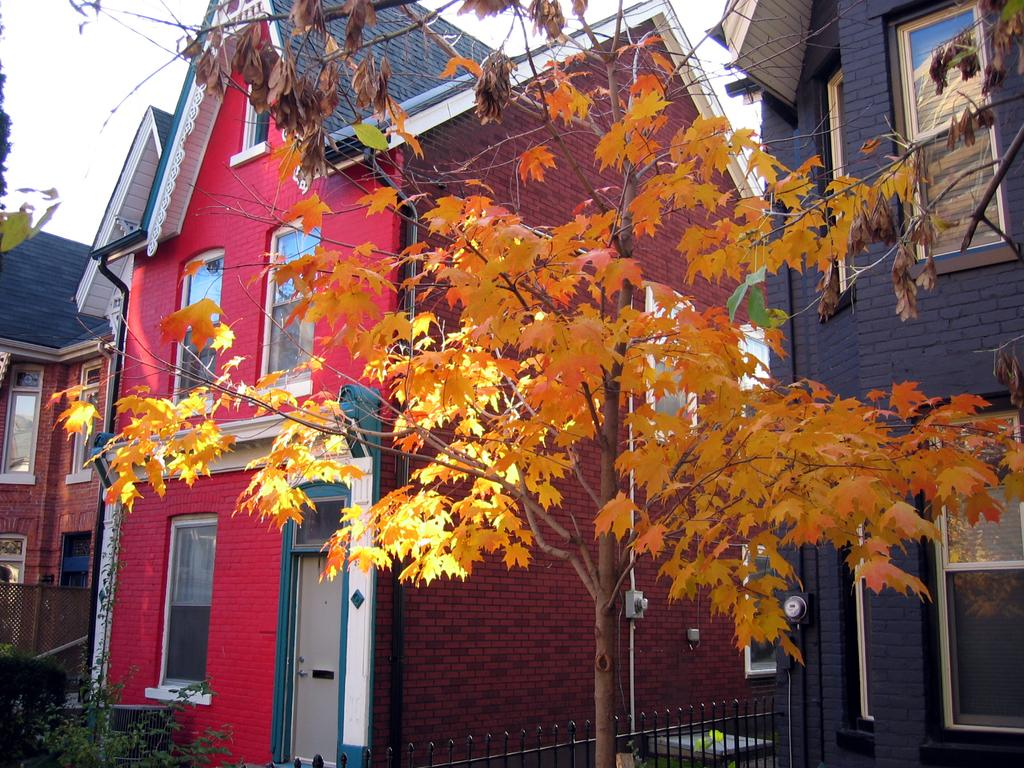What type of structures can be seen in the image? There are buildings in the image. What other natural elements are present in the image? There are trees and plants in the image. What can be seen in the background of the image? The sky is visible in the background of the image. Is there a crib visible in the image during the rainstorm? There is no crib or rainstorm present in the image; it features buildings, trees, plants, and a visible sky. 